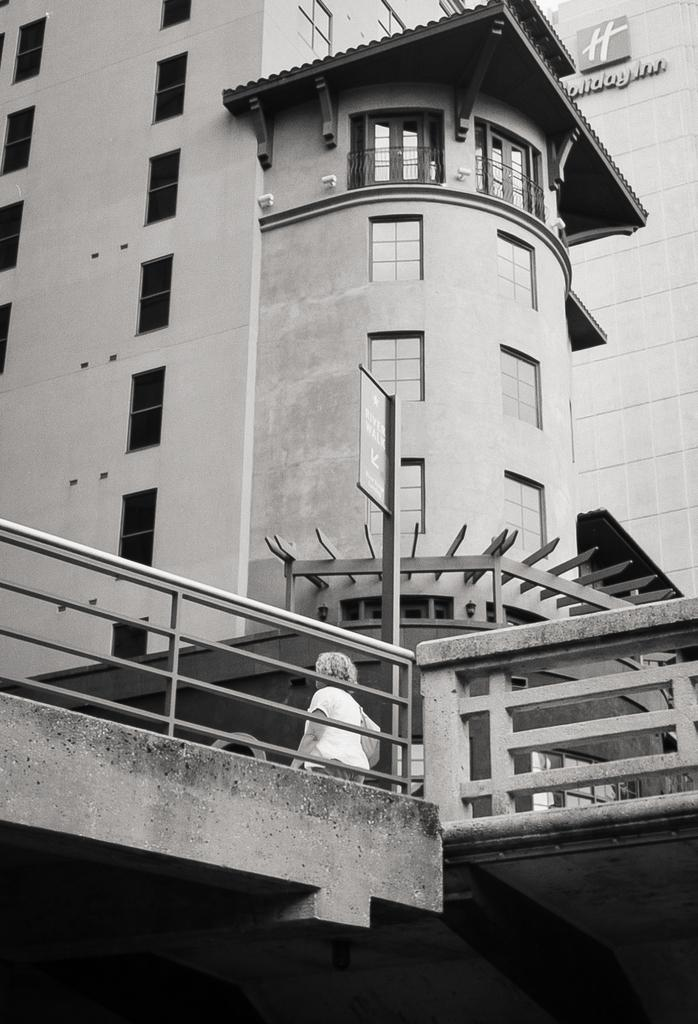What structure is visible in the image? There is a building in the image. Can you describe the person at the bottom of the image? The person is visible at the bottom of the image, and they are wearing clothes. What is the pole in the middle of the image used for? The purpose of the pole in the middle of the image is not specified, but it could be used for various purposes such as lighting or signage. What type of baseball team is represented by the design on the person's shirt in the image? There is no baseball team or design mentioned or visible on the person's shirt in the image. 